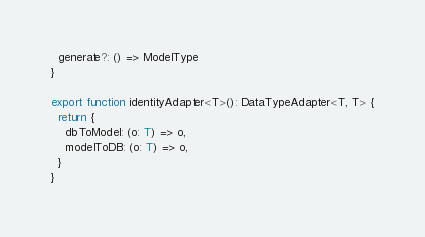<code> <loc_0><loc_0><loc_500><loc_500><_TypeScript_>  generate?: () => ModelType
}

export function identityAdapter<T>(): DataTypeAdapter<T, T> {
  return {
    dbToModel: (o: T) => o,
    modelToDB: (o: T) => o,
  }
}
</code> 